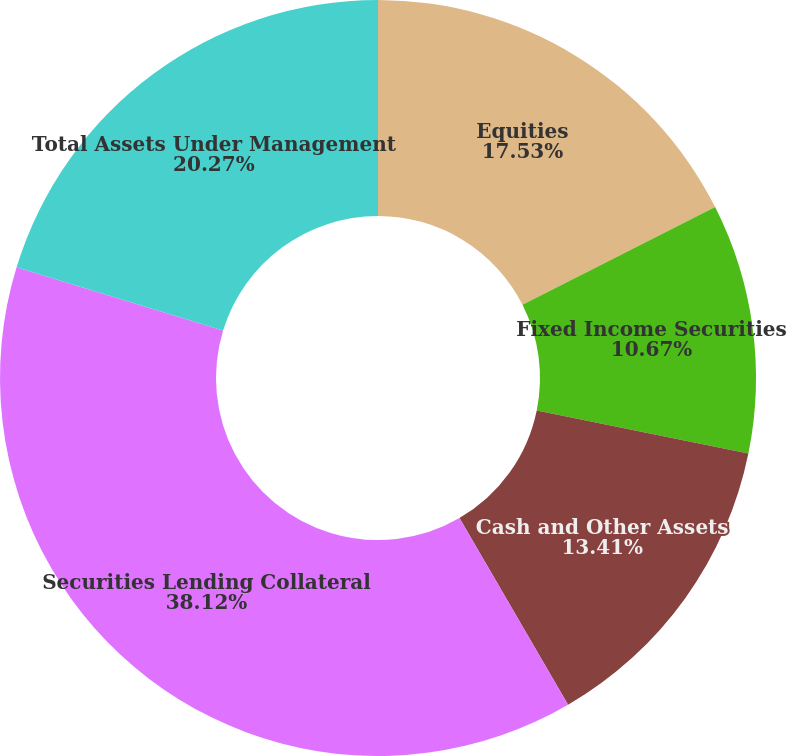<chart> <loc_0><loc_0><loc_500><loc_500><pie_chart><fcel>Equities<fcel>Fixed Income Securities<fcel>Cash and Other Assets<fcel>Securities Lending Collateral<fcel>Total Assets Under Management<nl><fcel>17.53%<fcel>10.67%<fcel>13.41%<fcel>38.11%<fcel>20.27%<nl></chart> 